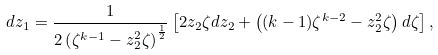Convert formula to latex. <formula><loc_0><loc_0><loc_500><loc_500>d z _ { 1 } = \frac { 1 } { 2 \left ( \zeta ^ { k - 1 } - z _ { 2 } ^ { 2 } \zeta \right ) ^ { \frac { 1 } { 2 } } } \left [ 2 z _ { 2 } \zeta d z _ { 2 } + \left ( ( k - 1 ) \zeta ^ { k - 2 } - z _ { 2 } ^ { 2 } \zeta \right ) d \zeta \right ] ,</formula> 